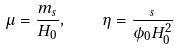Convert formula to latex. <formula><loc_0><loc_0><loc_500><loc_500>\mu = \frac { m _ { s } } { H _ { 0 } } , \quad \eta = \frac { _ { s } } { \phi _ { 0 } H _ { 0 } ^ { 2 } }</formula> 